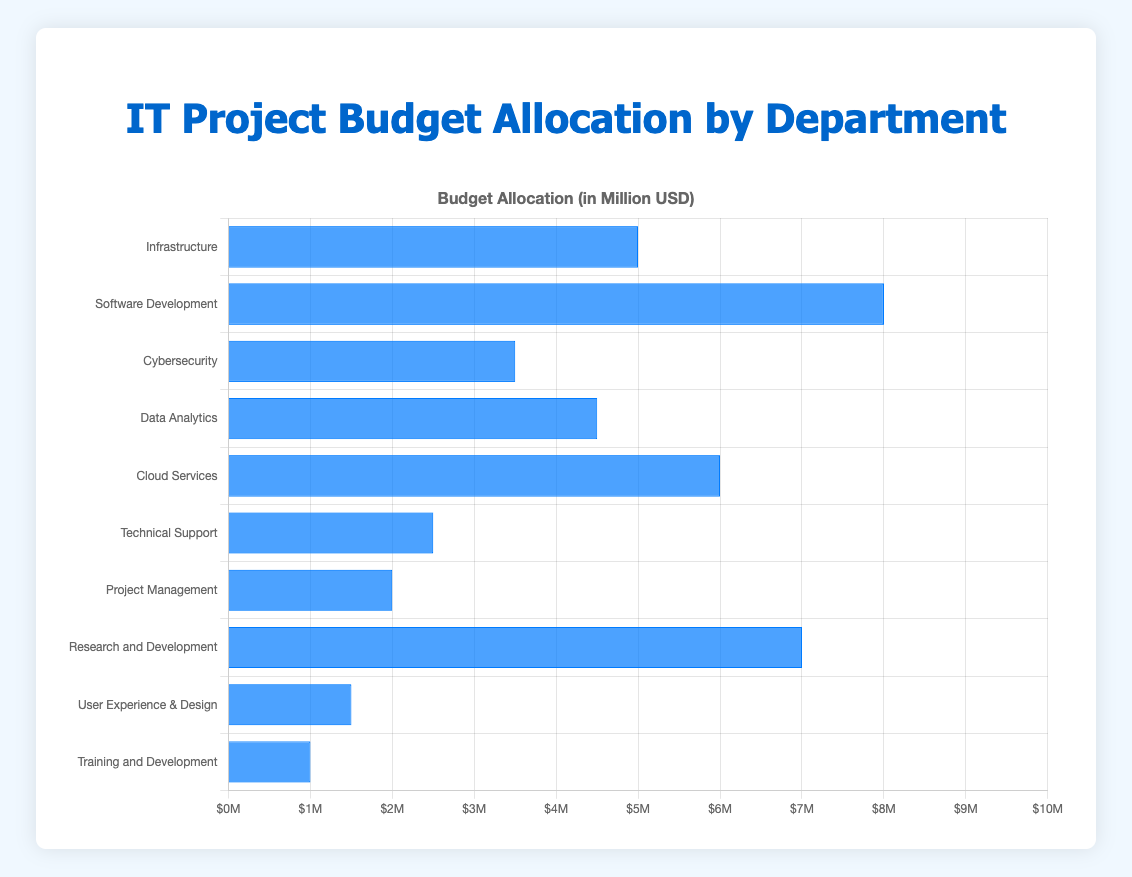Which department has the highest budget allocation? By examining the heights of the bars in the chart, it's evident that the Software Development department has the highest bar, representing the highest budget allocation.
Answer: Software Development Which department has the lowest budget allocation? Observing the chart, the Training and Development department has the shortest bar, indicating it has the lowest budget allocation.
Answer: Training and Development How much more budget does the Cloud Services department have compared to the Technical Support department? The chart shows Cloud Services with a budget of 6.0 million USD and Technical Support with 2.5 million USD. The difference is calculated as 6.0 - 2.5 = 3.5 million USD.
Answer: 3.5 million USD What is the combined budget for Infrastructure and Data Analytics departments? The chart indicates that Infrastructure has a budget of 5.0 million USD, and Data Analytics has 4.5 million USD. The combined budget is 5.0 + 4.5 = 9.5 million USD.
Answer: 9.5 million USD Which department's budget is closest to the average budget of all departments? First, calculate the total budget: 5 + 8 + 3.5 + 4.5 + 6 + 2.5 + 2 + 7 + 1.5 + 1 = 41 million USD. Then, calculate the average by dividing the total by the number of departments (10): 41 / 10 = 4.1 million USD. By comparing, the budget of Data Analytics (4.5 million USD) is closest to the average.
Answer: Data Analytics How many departments have a budget less than 3 million USD? By scanning the chart, departments with budgets less than 3 million USD are Technical Support, Project Management, User Experience & Design, and Training and Development, totaling 4 departments.
Answer: 4 Which departments have equal or higher budget allocation than the Project Management department? The chart shows the Project Management department with a budget of 2.0 million USD. The departments with equal or higher budgets are Infrastructure, Software Development, Cybersecurity, Data Analytics, Cloud Services, Technical Support, and Research and Development.
Answer: 7 departments What's the total budget allocation for Cybersecurity, Data Analytics, and Cloud Services? The chart indicates their respective budgets are 3.5 million USD, 4.5 million USD, and 6.0 million USD. Adding them together gives 3.5 + 4.5 + 6.0 = 14.0 million USD.
Answer: 14.0 million USD Which department has the second-highest budget allocation? The chart shows the highest allocation is Software Development with 8.0 million USD. The next highest bar represents Research and Development with 7.0 million USD.
Answer: Research and Development Compare the budgets of User Experience & Design and Training and Development. Which department has a higher budget, and by how much? The chart shows User Experience & Design with a budget of 1.5 million USD and Training and Development with 1.0 million USD. Calculating the difference: 1.5 - 1.0 = 0.5 million USD. User Experience & Design has a higher budget by 0.5 million USD.
Answer: User Experience & Design, 0.5 million USD 